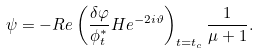<formula> <loc_0><loc_0><loc_500><loc_500>\psi = - R e \left ( \frac { \delta \varphi } { \phi _ { t } ^ { \ast } } H e ^ { - 2 i \vartheta } \right ) _ { t = t _ { c } } \frac { 1 } { \mu + 1 } .</formula> 